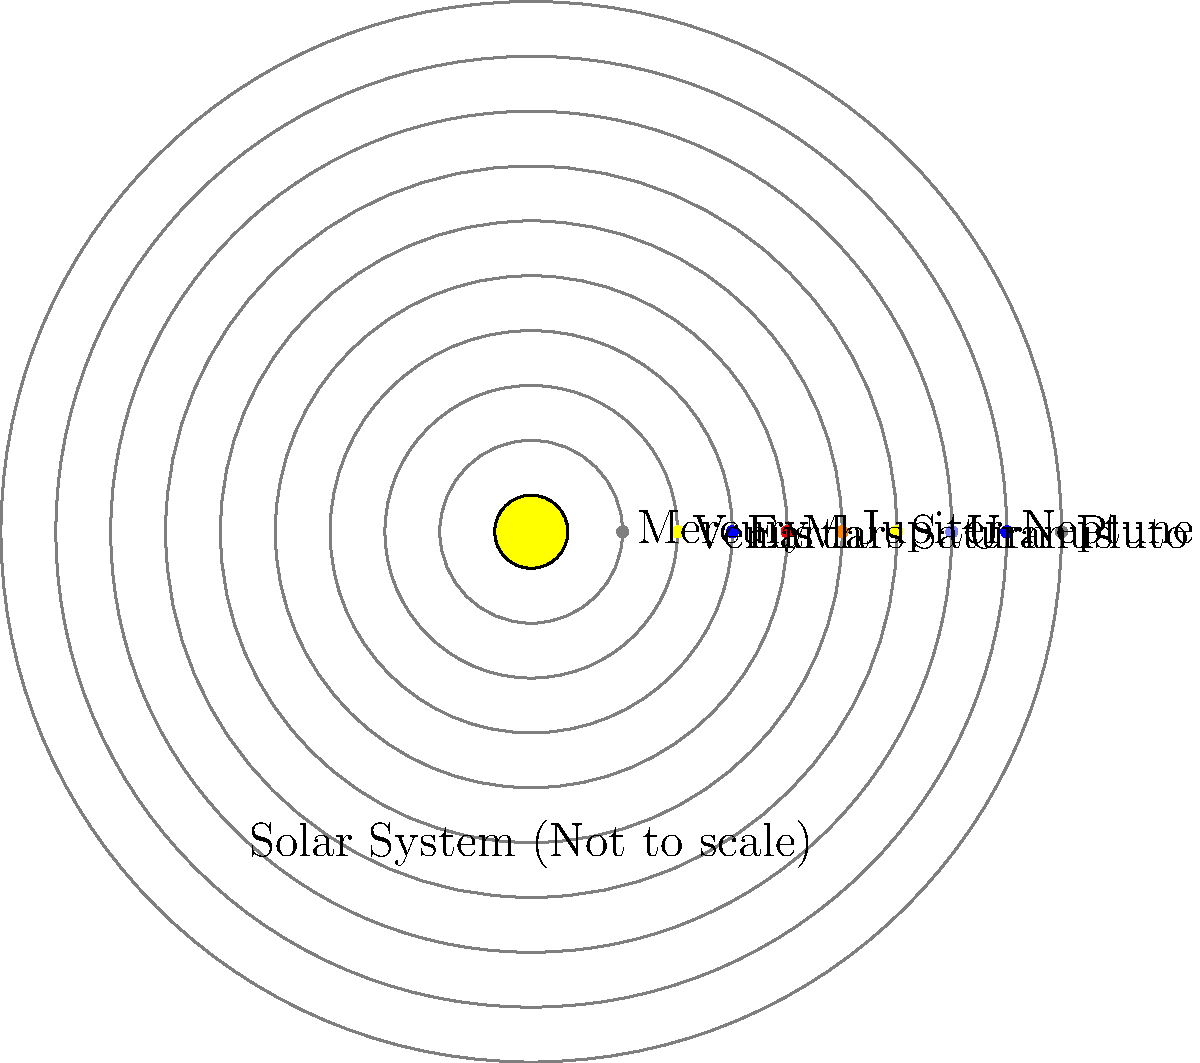In the diagram of our solar system (not to scale), which planet is represented by the largest dot, and how does its size compare to Earth's? To answer this question, we need to follow these steps:

1. Observe the diagram and identify the largest dot representing a planet.
2. Recall the relative sizes of planets in our solar system.
3. Compare the size of the identified planet to Earth's size.

Step 1: In the diagram, we can see that the largest dot represents Jupiter.

Step 2: Jupiter is the largest planet in our solar system. Let's recall some key facts about Jupiter's size:
- Jupiter's diameter is approximately 142,984 km
- Earth's diameter is approximately 12,742 km

Step 3: To compare Jupiter's size to Earth's, we can calculate the ratio:

$$ \text{Ratio} = \frac{\text{Jupiter's diameter}}{\text{Earth's diameter}} = \frac{142,984 \text{ km}}{12,742 \text{ km}} \approx 11.22 $$

This means that Jupiter is about 11.22 times larger in diameter than Earth.

In terms of volume, the difference is even more significant:

$$ \text{Volume ratio} = \left(\frac{\text{Jupiter's diameter}}{\text{Earth's diameter}}\right)^3 \approx 11.22^3 \approx 1,412 $$

So, Jupiter's volume is about 1,412 times greater than Earth's.
Answer: Jupiter; approximately 11 times larger in diameter and 1,400 times larger in volume than Earth. 